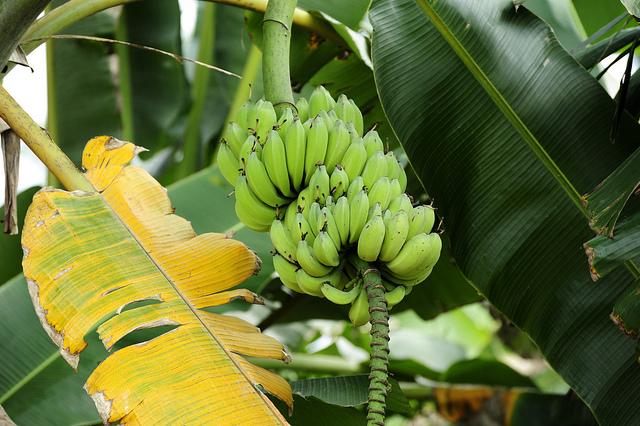Is it ripped?
Concise answer only. No. Will these fruits get much bigger before being picked?
Give a very brief answer. Yes. What color will this fruit become when it ripens?
Keep it brief. Yellow. What number of green bananas are in the bunch?
Answer briefly. 50. 